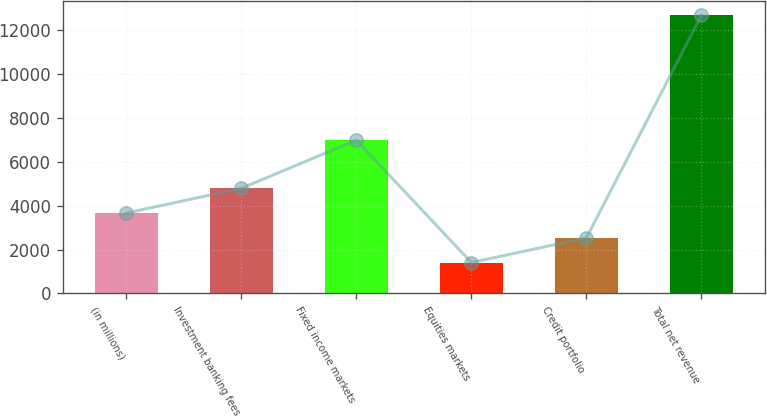Convert chart to OTSL. <chart><loc_0><loc_0><loc_500><loc_500><bar_chart><fcel>(in millions)<fcel>Investment banking fees<fcel>Fixed income markets<fcel>Equities markets<fcel>Credit portfolio<fcel>Total net revenue<nl><fcel>3661.6<fcel>4789.4<fcel>6987<fcel>1406<fcel>2533.8<fcel>12684<nl></chart> 